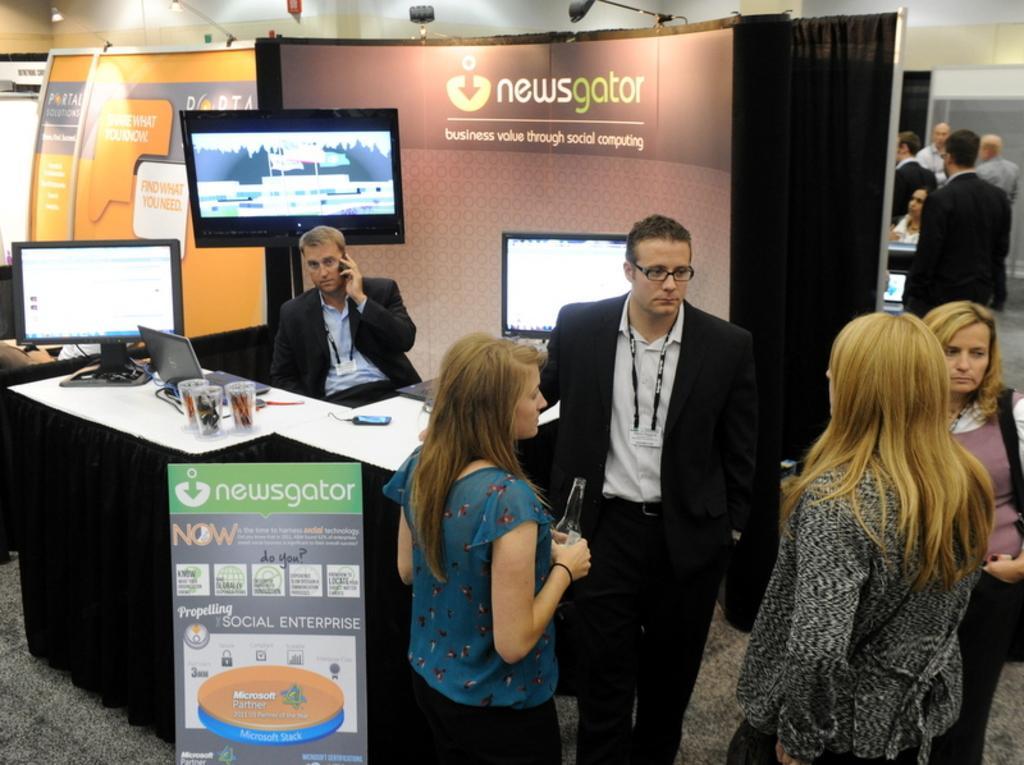How would you summarize this image in a sentence or two? In this image I can see the group of people with different color dresses. I can see one person sitting in-front of the table. On the table I can see the screens, laptop, cups and few more objects. In the background I can see the boards and few more people. I can see the lights at the top. 